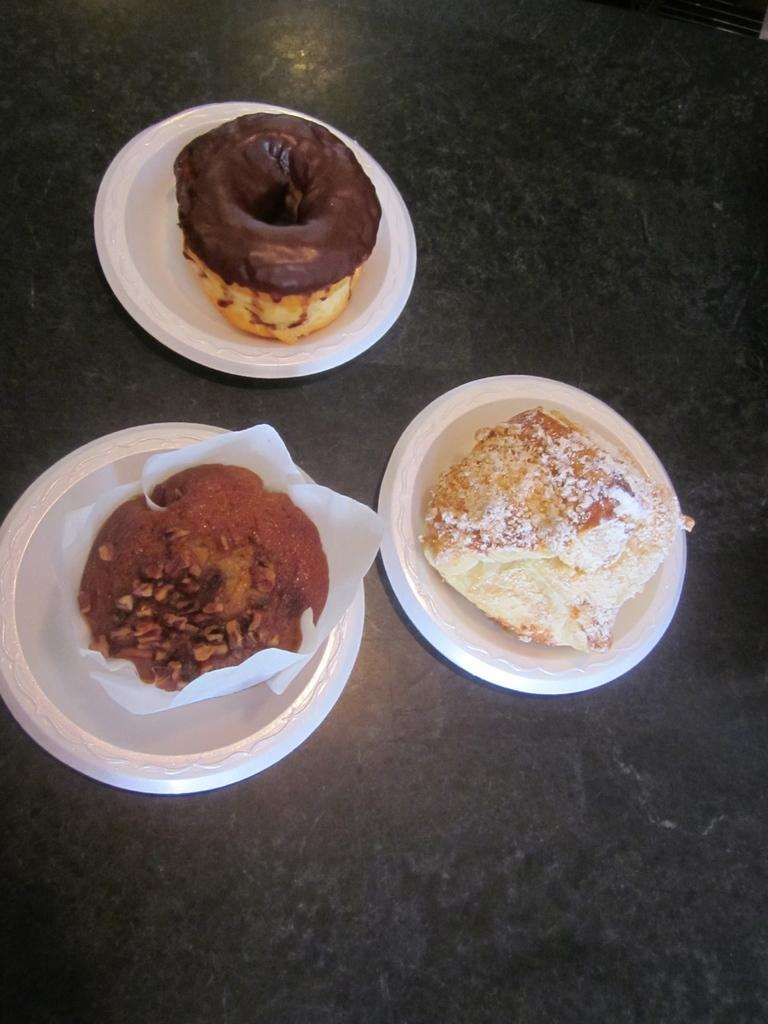How many plates are visible in the image? There are three plates in the image. What is on each of the plates? Each plate contains different food items. Where are the plates located in the image? The plates are placed on the floor. What type of calculator is on the shelf in the image? There is no shelf or calculator present in the image. 